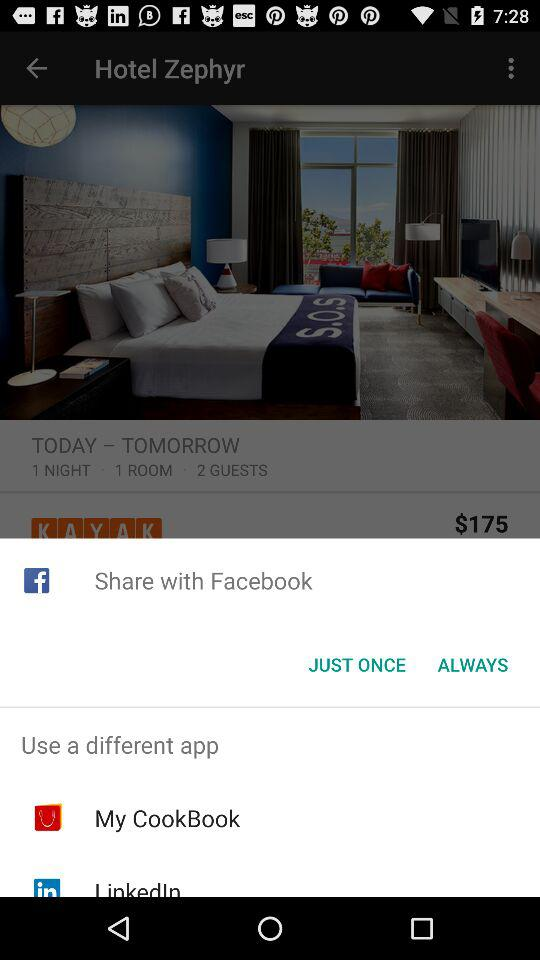How many guests are allowed in one room? The number of guests allowed in one room is 2. 